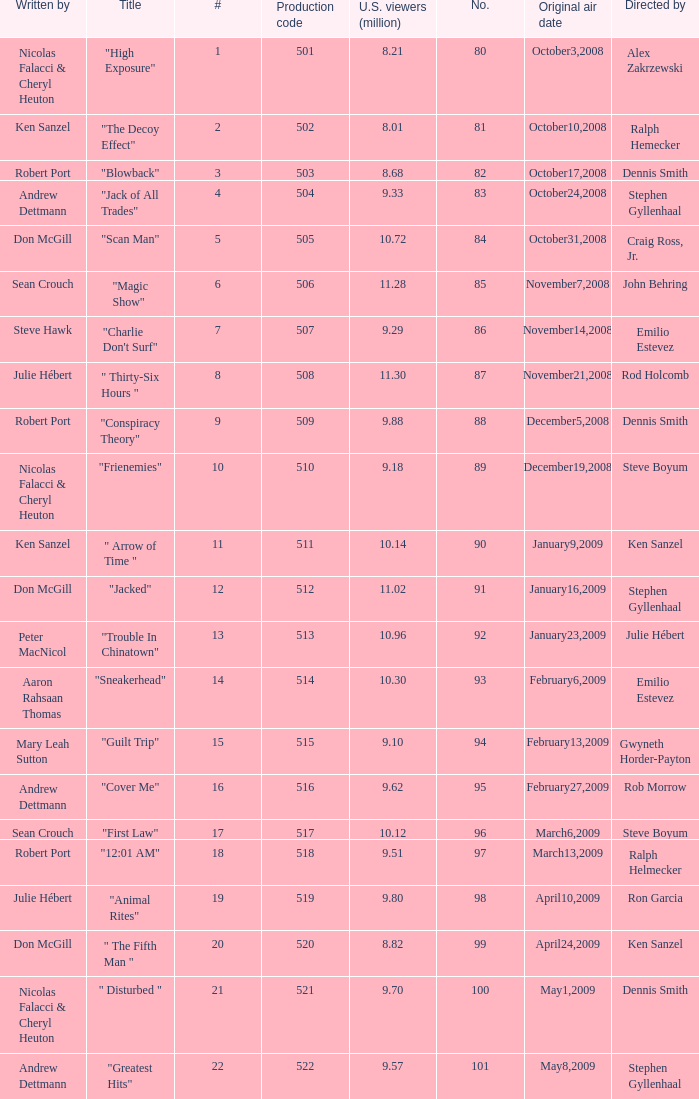What episode number was directed by Craig Ross, Jr. 5.0. Parse the full table. {'header': ['Written by', 'Title', '#', 'Production code', 'U.S. viewers (million)', 'No.', 'Original air date', 'Directed by'], 'rows': [['Nicolas Falacci & Cheryl Heuton', '"High Exposure"', '1', '501', '8.21', '80', 'October3,2008', 'Alex Zakrzewski'], ['Ken Sanzel', '"The Decoy Effect"', '2', '502', '8.01', '81', 'October10,2008', 'Ralph Hemecker'], ['Robert Port', '"Blowback"', '3', '503', '8.68', '82', 'October17,2008', 'Dennis Smith'], ['Andrew Dettmann', '"Jack of All Trades"', '4', '504', '9.33', '83', 'October24,2008', 'Stephen Gyllenhaal'], ['Don McGill', '"Scan Man"', '5', '505', '10.72', '84', 'October31,2008', 'Craig Ross, Jr.'], ['Sean Crouch', '"Magic Show"', '6', '506', '11.28', '85', 'November7,2008', 'John Behring'], ['Steve Hawk', '"Charlie Don\'t Surf"', '7', '507', '9.29', '86', 'November14,2008', 'Emilio Estevez'], ['Julie Hébert', '" Thirty-Six Hours "', '8', '508', '11.30', '87', 'November21,2008', 'Rod Holcomb'], ['Robert Port', '"Conspiracy Theory"', '9', '509', '9.88', '88', 'December5,2008', 'Dennis Smith'], ['Nicolas Falacci & Cheryl Heuton', '"Frienemies"', '10', '510', '9.18', '89', 'December19,2008', 'Steve Boyum'], ['Ken Sanzel', '" Arrow of Time "', '11', '511', '10.14', '90', 'January9,2009', 'Ken Sanzel'], ['Don McGill', '"Jacked"', '12', '512', '11.02', '91', 'January16,2009', 'Stephen Gyllenhaal'], ['Peter MacNicol', '"Trouble In Chinatown"', '13', '513', '10.96', '92', 'January23,2009', 'Julie Hébert'], ['Aaron Rahsaan Thomas', '"Sneakerhead"', '14', '514', '10.30', '93', 'February6,2009', 'Emilio Estevez'], ['Mary Leah Sutton', '"Guilt Trip"', '15', '515', '9.10', '94', 'February13,2009', 'Gwyneth Horder-Payton'], ['Andrew Dettmann', '"Cover Me"', '16', '516', '9.62', '95', 'February27,2009', 'Rob Morrow'], ['Sean Crouch', '"First Law"', '17', '517', '10.12', '96', 'March6,2009', 'Steve Boyum'], ['Robert Port', '"12:01 AM"', '18', '518', '9.51', '97', 'March13,2009', 'Ralph Helmecker'], ['Julie Hébert', '"Animal Rites"', '19', '519', '9.80', '98', 'April10,2009', 'Ron Garcia'], ['Don McGill', '" The Fifth Man "', '20', '520', '8.82', '99', 'April24,2009', 'Ken Sanzel'], ['Nicolas Falacci & Cheryl Heuton', '" Disturbed "', '21', '521', '9.70', '100', 'May1,2009', 'Dennis Smith'], ['Andrew Dettmann', '"Greatest Hits"', '22', '522', '9.57', '101', 'May8,2009', 'Stephen Gyllenhaal']]} 